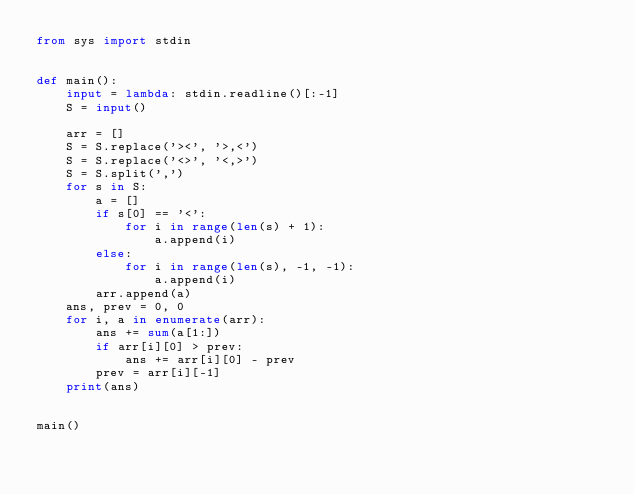Convert code to text. <code><loc_0><loc_0><loc_500><loc_500><_Python_>from sys import stdin


def main():
    input = lambda: stdin.readline()[:-1]
    S = input()

    arr = []
    S = S.replace('><', '>,<')
    S = S.replace('<>', '<,>')
    S = S.split(',')
    for s in S:
        a = []
        if s[0] == '<':
            for i in range(len(s) + 1):
                a.append(i)
        else:
            for i in range(len(s), -1, -1):
                a.append(i)
        arr.append(a)
    ans, prev = 0, 0
    for i, a in enumerate(arr):
        ans += sum(a[1:])
        if arr[i][0] > prev:
            ans += arr[i][0] - prev
        prev = arr[i][-1]
    print(ans)


main()
</code> 